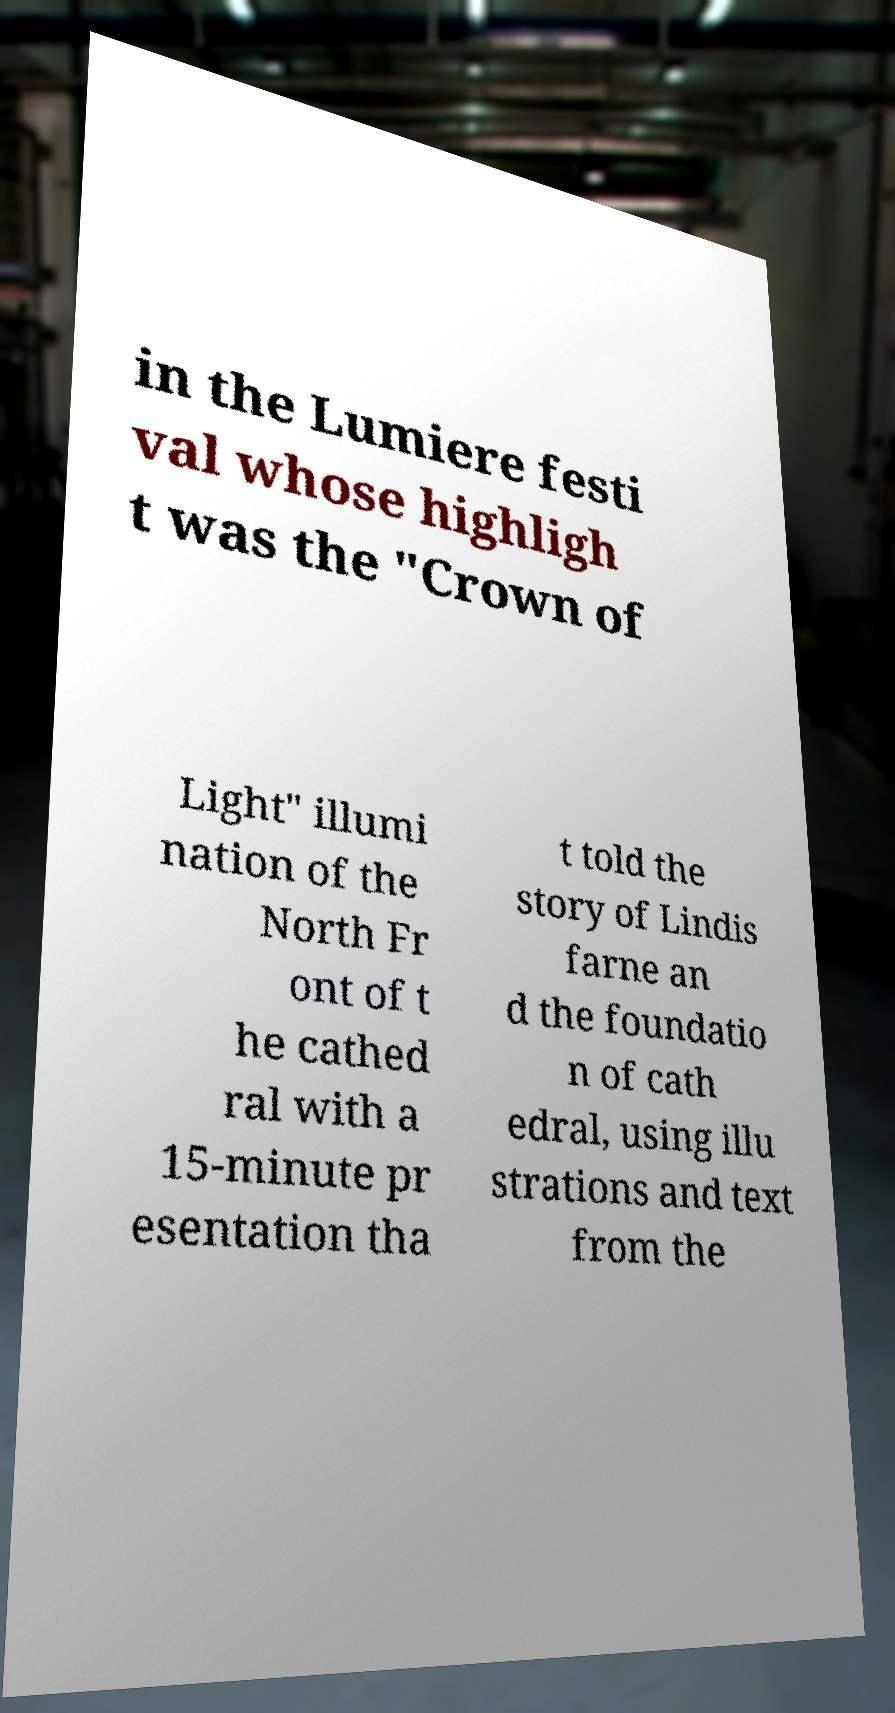Can you read and provide the text displayed in the image?This photo seems to have some interesting text. Can you extract and type it out for me? in the Lumiere festi val whose highligh t was the "Crown of Light" illumi nation of the North Fr ont of t he cathed ral with a 15-minute pr esentation tha t told the story of Lindis farne an d the foundatio n of cath edral, using illu strations and text from the 